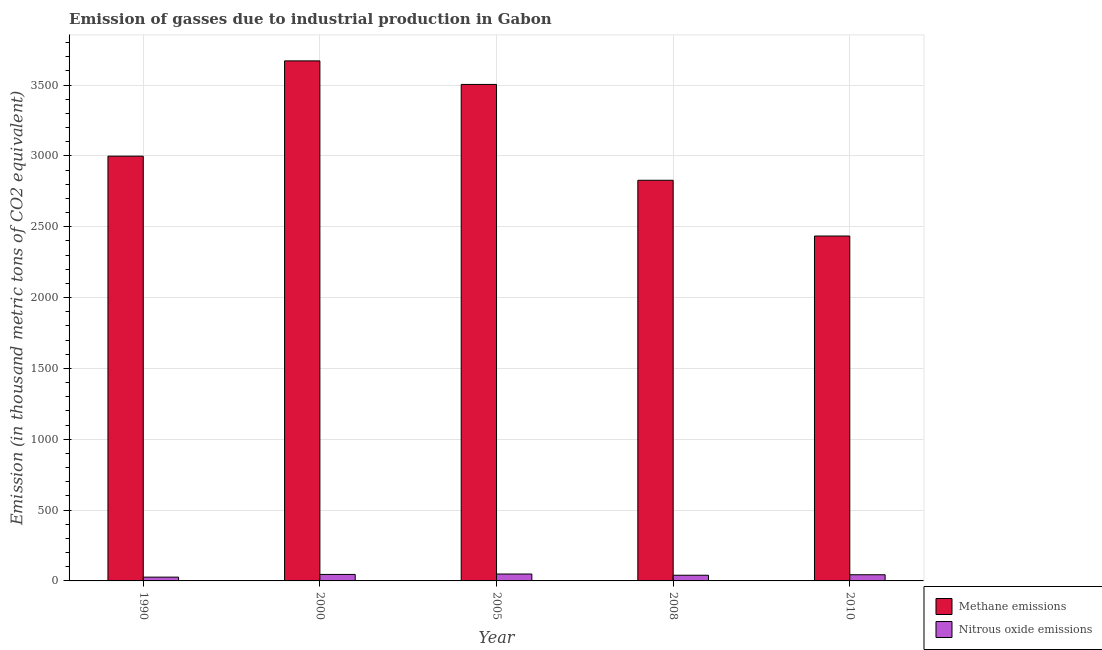Are the number of bars per tick equal to the number of legend labels?
Give a very brief answer. Yes. How many bars are there on the 5th tick from the right?
Your answer should be compact. 2. What is the label of the 1st group of bars from the left?
Your answer should be compact. 1990. In how many cases, is the number of bars for a given year not equal to the number of legend labels?
Ensure brevity in your answer.  0. What is the amount of methane emissions in 2000?
Your response must be concise. 3670.7. Across all years, what is the maximum amount of methane emissions?
Offer a terse response. 3670.7. Across all years, what is the minimum amount of nitrous oxide emissions?
Make the answer very short. 26.7. In which year was the amount of methane emissions maximum?
Keep it short and to the point. 2000. In which year was the amount of nitrous oxide emissions minimum?
Offer a terse response. 1990. What is the total amount of nitrous oxide emissions in the graph?
Keep it short and to the point. 204.9. What is the difference between the amount of methane emissions in 1990 and that in 2000?
Your answer should be compact. -672.5. What is the difference between the amount of nitrous oxide emissions in 1990 and the amount of methane emissions in 2008?
Make the answer very short. -13.4. What is the average amount of nitrous oxide emissions per year?
Your response must be concise. 40.98. In how many years, is the amount of methane emissions greater than 1800 thousand metric tons?
Offer a very short reply. 5. What is the ratio of the amount of methane emissions in 1990 to that in 2005?
Provide a short and direct response. 0.86. Is the difference between the amount of nitrous oxide emissions in 1990 and 2008 greater than the difference between the amount of methane emissions in 1990 and 2008?
Keep it short and to the point. No. What is the difference between the highest and the second highest amount of nitrous oxide emissions?
Your answer should be very brief. 2.9. What is the difference between the highest and the lowest amount of methane emissions?
Offer a terse response. 1236.3. In how many years, is the amount of nitrous oxide emissions greater than the average amount of nitrous oxide emissions taken over all years?
Your response must be concise. 3. What does the 1st bar from the left in 2000 represents?
Offer a very short reply. Methane emissions. What does the 1st bar from the right in 2000 represents?
Offer a very short reply. Nitrous oxide emissions. How many bars are there?
Your answer should be very brief. 10. How many years are there in the graph?
Provide a succinct answer. 5. Does the graph contain grids?
Your answer should be compact. Yes. How many legend labels are there?
Your answer should be compact. 2. How are the legend labels stacked?
Give a very brief answer. Vertical. What is the title of the graph?
Ensure brevity in your answer.  Emission of gasses due to industrial production in Gabon. Does "Private creditors" appear as one of the legend labels in the graph?
Give a very brief answer. No. What is the label or title of the X-axis?
Make the answer very short. Year. What is the label or title of the Y-axis?
Make the answer very short. Emission (in thousand metric tons of CO2 equivalent). What is the Emission (in thousand metric tons of CO2 equivalent) in Methane emissions in 1990?
Your answer should be compact. 2998.2. What is the Emission (in thousand metric tons of CO2 equivalent) of Nitrous oxide emissions in 1990?
Ensure brevity in your answer.  26.7. What is the Emission (in thousand metric tons of CO2 equivalent) of Methane emissions in 2000?
Make the answer very short. 3670.7. What is the Emission (in thousand metric tons of CO2 equivalent) of Nitrous oxide emissions in 2000?
Provide a short and direct response. 45.8. What is the Emission (in thousand metric tons of CO2 equivalent) of Methane emissions in 2005?
Provide a succinct answer. 3504.5. What is the Emission (in thousand metric tons of CO2 equivalent) in Nitrous oxide emissions in 2005?
Provide a short and direct response. 48.7. What is the Emission (in thousand metric tons of CO2 equivalent) in Methane emissions in 2008?
Keep it short and to the point. 2828. What is the Emission (in thousand metric tons of CO2 equivalent) in Nitrous oxide emissions in 2008?
Provide a succinct answer. 40.1. What is the Emission (in thousand metric tons of CO2 equivalent) of Methane emissions in 2010?
Offer a terse response. 2434.4. What is the Emission (in thousand metric tons of CO2 equivalent) of Nitrous oxide emissions in 2010?
Your answer should be very brief. 43.6. Across all years, what is the maximum Emission (in thousand metric tons of CO2 equivalent) of Methane emissions?
Keep it short and to the point. 3670.7. Across all years, what is the maximum Emission (in thousand metric tons of CO2 equivalent) in Nitrous oxide emissions?
Your response must be concise. 48.7. Across all years, what is the minimum Emission (in thousand metric tons of CO2 equivalent) of Methane emissions?
Your response must be concise. 2434.4. Across all years, what is the minimum Emission (in thousand metric tons of CO2 equivalent) in Nitrous oxide emissions?
Your answer should be very brief. 26.7. What is the total Emission (in thousand metric tons of CO2 equivalent) of Methane emissions in the graph?
Offer a very short reply. 1.54e+04. What is the total Emission (in thousand metric tons of CO2 equivalent) in Nitrous oxide emissions in the graph?
Provide a succinct answer. 204.9. What is the difference between the Emission (in thousand metric tons of CO2 equivalent) in Methane emissions in 1990 and that in 2000?
Ensure brevity in your answer.  -672.5. What is the difference between the Emission (in thousand metric tons of CO2 equivalent) in Nitrous oxide emissions in 1990 and that in 2000?
Give a very brief answer. -19.1. What is the difference between the Emission (in thousand metric tons of CO2 equivalent) in Methane emissions in 1990 and that in 2005?
Your answer should be compact. -506.3. What is the difference between the Emission (in thousand metric tons of CO2 equivalent) of Methane emissions in 1990 and that in 2008?
Offer a terse response. 170.2. What is the difference between the Emission (in thousand metric tons of CO2 equivalent) of Nitrous oxide emissions in 1990 and that in 2008?
Offer a terse response. -13.4. What is the difference between the Emission (in thousand metric tons of CO2 equivalent) in Methane emissions in 1990 and that in 2010?
Provide a succinct answer. 563.8. What is the difference between the Emission (in thousand metric tons of CO2 equivalent) of Nitrous oxide emissions in 1990 and that in 2010?
Give a very brief answer. -16.9. What is the difference between the Emission (in thousand metric tons of CO2 equivalent) in Methane emissions in 2000 and that in 2005?
Give a very brief answer. 166.2. What is the difference between the Emission (in thousand metric tons of CO2 equivalent) in Nitrous oxide emissions in 2000 and that in 2005?
Offer a very short reply. -2.9. What is the difference between the Emission (in thousand metric tons of CO2 equivalent) in Methane emissions in 2000 and that in 2008?
Your response must be concise. 842.7. What is the difference between the Emission (in thousand metric tons of CO2 equivalent) of Nitrous oxide emissions in 2000 and that in 2008?
Ensure brevity in your answer.  5.7. What is the difference between the Emission (in thousand metric tons of CO2 equivalent) in Methane emissions in 2000 and that in 2010?
Make the answer very short. 1236.3. What is the difference between the Emission (in thousand metric tons of CO2 equivalent) of Nitrous oxide emissions in 2000 and that in 2010?
Provide a succinct answer. 2.2. What is the difference between the Emission (in thousand metric tons of CO2 equivalent) of Methane emissions in 2005 and that in 2008?
Ensure brevity in your answer.  676.5. What is the difference between the Emission (in thousand metric tons of CO2 equivalent) of Nitrous oxide emissions in 2005 and that in 2008?
Give a very brief answer. 8.6. What is the difference between the Emission (in thousand metric tons of CO2 equivalent) of Methane emissions in 2005 and that in 2010?
Make the answer very short. 1070.1. What is the difference between the Emission (in thousand metric tons of CO2 equivalent) in Nitrous oxide emissions in 2005 and that in 2010?
Your answer should be compact. 5.1. What is the difference between the Emission (in thousand metric tons of CO2 equivalent) in Methane emissions in 2008 and that in 2010?
Your answer should be compact. 393.6. What is the difference between the Emission (in thousand metric tons of CO2 equivalent) in Nitrous oxide emissions in 2008 and that in 2010?
Provide a succinct answer. -3.5. What is the difference between the Emission (in thousand metric tons of CO2 equivalent) of Methane emissions in 1990 and the Emission (in thousand metric tons of CO2 equivalent) of Nitrous oxide emissions in 2000?
Your answer should be very brief. 2952.4. What is the difference between the Emission (in thousand metric tons of CO2 equivalent) of Methane emissions in 1990 and the Emission (in thousand metric tons of CO2 equivalent) of Nitrous oxide emissions in 2005?
Provide a short and direct response. 2949.5. What is the difference between the Emission (in thousand metric tons of CO2 equivalent) in Methane emissions in 1990 and the Emission (in thousand metric tons of CO2 equivalent) in Nitrous oxide emissions in 2008?
Keep it short and to the point. 2958.1. What is the difference between the Emission (in thousand metric tons of CO2 equivalent) of Methane emissions in 1990 and the Emission (in thousand metric tons of CO2 equivalent) of Nitrous oxide emissions in 2010?
Provide a succinct answer. 2954.6. What is the difference between the Emission (in thousand metric tons of CO2 equivalent) of Methane emissions in 2000 and the Emission (in thousand metric tons of CO2 equivalent) of Nitrous oxide emissions in 2005?
Offer a very short reply. 3622. What is the difference between the Emission (in thousand metric tons of CO2 equivalent) of Methane emissions in 2000 and the Emission (in thousand metric tons of CO2 equivalent) of Nitrous oxide emissions in 2008?
Keep it short and to the point. 3630.6. What is the difference between the Emission (in thousand metric tons of CO2 equivalent) in Methane emissions in 2000 and the Emission (in thousand metric tons of CO2 equivalent) in Nitrous oxide emissions in 2010?
Your response must be concise. 3627.1. What is the difference between the Emission (in thousand metric tons of CO2 equivalent) of Methane emissions in 2005 and the Emission (in thousand metric tons of CO2 equivalent) of Nitrous oxide emissions in 2008?
Keep it short and to the point. 3464.4. What is the difference between the Emission (in thousand metric tons of CO2 equivalent) of Methane emissions in 2005 and the Emission (in thousand metric tons of CO2 equivalent) of Nitrous oxide emissions in 2010?
Keep it short and to the point. 3460.9. What is the difference between the Emission (in thousand metric tons of CO2 equivalent) in Methane emissions in 2008 and the Emission (in thousand metric tons of CO2 equivalent) in Nitrous oxide emissions in 2010?
Make the answer very short. 2784.4. What is the average Emission (in thousand metric tons of CO2 equivalent) of Methane emissions per year?
Provide a short and direct response. 3087.16. What is the average Emission (in thousand metric tons of CO2 equivalent) in Nitrous oxide emissions per year?
Keep it short and to the point. 40.98. In the year 1990, what is the difference between the Emission (in thousand metric tons of CO2 equivalent) of Methane emissions and Emission (in thousand metric tons of CO2 equivalent) of Nitrous oxide emissions?
Offer a terse response. 2971.5. In the year 2000, what is the difference between the Emission (in thousand metric tons of CO2 equivalent) in Methane emissions and Emission (in thousand metric tons of CO2 equivalent) in Nitrous oxide emissions?
Ensure brevity in your answer.  3624.9. In the year 2005, what is the difference between the Emission (in thousand metric tons of CO2 equivalent) of Methane emissions and Emission (in thousand metric tons of CO2 equivalent) of Nitrous oxide emissions?
Your answer should be very brief. 3455.8. In the year 2008, what is the difference between the Emission (in thousand metric tons of CO2 equivalent) in Methane emissions and Emission (in thousand metric tons of CO2 equivalent) in Nitrous oxide emissions?
Your answer should be very brief. 2787.9. In the year 2010, what is the difference between the Emission (in thousand metric tons of CO2 equivalent) of Methane emissions and Emission (in thousand metric tons of CO2 equivalent) of Nitrous oxide emissions?
Offer a very short reply. 2390.8. What is the ratio of the Emission (in thousand metric tons of CO2 equivalent) of Methane emissions in 1990 to that in 2000?
Ensure brevity in your answer.  0.82. What is the ratio of the Emission (in thousand metric tons of CO2 equivalent) of Nitrous oxide emissions in 1990 to that in 2000?
Make the answer very short. 0.58. What is the ratio of the Emission (in thousand metric tons of CO2 equivalent) of Methane emissions in 1990 to that in 2005?
Offer a terse response. 0.86. What is the ratio of the Emission (in thousand metric tons of CO2 equivalent) in Nitrous oxide emissions in 1990 to that in 2005?
Your answer should be very brief. 0.55. What is the ratio of the Emission (in thousand metric tons of CO2 equivalent) of Methane emissions in 1990 to that in 2008?
Make the answer very short. 1.06. What is the ratio of the Emission (in thousand metric tons of CO2 equivalent) in Nitrous oxide emissions in 1990 to that in 2008?
Make the answer very short. 0.67. What is the ratio of the Emission (in thousand metric tons of CO2 equivalent) of Methane emissions in 1990 to that in 2010?
Your response must be concise. 1.23. What is the ratio of the Emission (in thousand metric tons of CO2 equivalent) of Nitrous oxide emissions in 1990 to that in 2010?
Your answer should be compact. 0.61. What is the ratio of the Emission (in thousand metric tons of CO2 equivalent) of Methane emissions in 2000 to that in 2005?
Your answer should be compact. 1.05. What is the ratio of the Emission (in thousand metric tons of CO2 equivalent) of Nitrous oxide emissions in 2000 to that in 2005?
Provide a succinct answer. 0.94. What is the ratio of the Emission (in thousand metric tons of CO2 equivalent) in Methane emissions in 2000 to that in 2008?
Provide a succinct answer. 1.3. What is the ratio of the Emission (in thousand metric tons of CO2 equivalent) of Nitrous oxide emissions in 2000 to that in 2008?
Keep it short and to the point. 1.14. What is the ratio of the Emission (in thousand metric tons of CO2 equivalent) in Methane emissions in 2000 to that in 2010?
Your answer should be very brief. 1.51. What is the ratio of the Emission (in thousand metric tons of CO2 equivalent) in Nitrous oxide emissions in 2000 to that in 2010?
Offer a very short reply. 1.05. What is the ratio of the Emission (in thousand metric tons of CO2 equivalent) in Methane emissions in 2005 to that in 2008?
Provide a succinct answer. 1.24. What is the ratio of the Emission (in thousand metric tons of CO2 equivalent) in Nitrous oxide emissions in 2005 to that in 2008?
Offer a very short reply. 1.21. What is the ratio of the Emission (in thousand metric tons of CO2 equivalent) of Methane emissions in 2005 to that in 2010?
Your response must be concise. 1.44. What is the ratio of the Emission (in thousand metric tons of CO2 equivalent) of Nitrous oxide emissions in 2005 to that in 2010?
Offer a terse response. 1.12. What is the ratio of the Emission (in thousand metric tons of CO2 equivalent) in Methane emissions in 2008 to that in 2010?
Your answer should be compact. 1.16. What is the ratio of the Emission (in thousand metric tons of CO2 equivalent) of Nitrous oxide emissions in 2008 to that in 2010?
Keep it short and to the point. 0.92. What is the difference between the highest and the second highest Emission (in thousand metric tons of CO2 equivalent) of Methane emissions?
Your answer should be compact. 166.2. What is the difference between the highest and the second highest Emission (in thousand metric tons of CO2 equivalent) of Nitrous oxide emissions?
Your answer should be very brief. 2.9. What is the difference between the highest and the lowest Emission (in thousand metric tons of CO2 equivalent) in Methane emissions?
Your answer should be very brief. 1236.3. What is the difference between the highest and the lowest Emission (in thousand metric tons of CO2 equivalent) in Nitrous oxide emissions?
Provide a short and direct response. 22. 